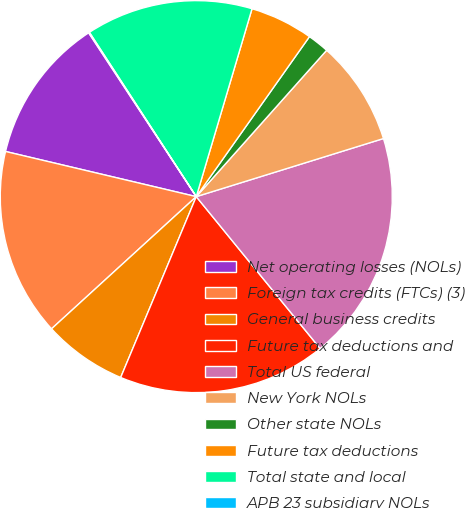Convert chart to OTSL. <chart><loc_0><loc_0><loc_500><loc_500><pie_chart><fcel>Net operating losses (NOLs)<fcel>Foreign tax credits (FTCs) (3)<fcel>General business credits<fcel>Future tax deductions and<fcel>Total US federal<fcel>New York NOLs<fcel>Other state NOLs<fcel>Future tax deductions<fcel>Total state and local<fcel>APB 23 subsidiary NOLs<nl><fcel>12.05%<fcel>15.48%<fcel>6.92%<fcel>17.19%<fcel>18.9%<fcel>8.63%<fcel>1.78%<fcel>5.21%<fcel>13.77%<fcel>0.07%<nl></chart> 